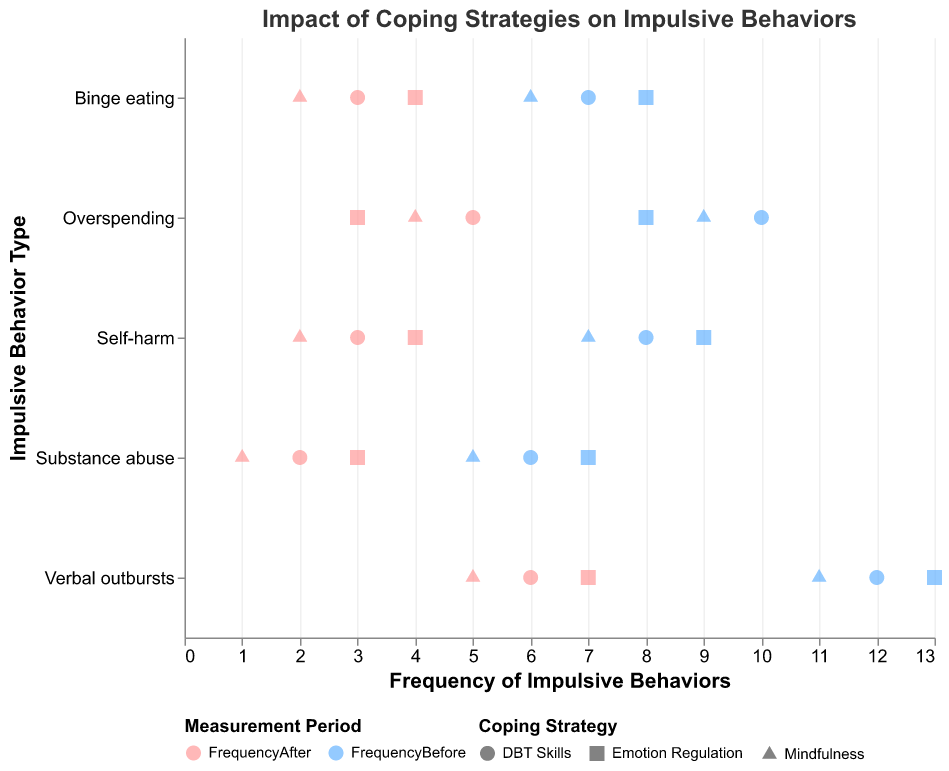What's the title of the plot? The text at the top of the plot typically represents the title, which provides a brief description of the plot's content.
Answer: Impact of Coping Strategies on Impulsive Behaviors What are the two periods represented in the plot? The legend next to the color scale provides information indicating the different periods along with their corresponding colors.
Answer: FrequencyBefore and FrequencyAfter What coping strategy is represented by the triangle shapes in the plot? The legend detailing the shape scale identifies the coping strategies along with their corresponding shapes.
Answer: Emotion Regulation Which impulsive behavior had the highest frequency before implementing coping strategies? By examining the x-values under "Frequency Before" for each behavior category on the y-axis, it's clear that "Verbal outbursts" has the highest frequency value at 13.
Answer: Verbal outbursts Which strategy seems to be most effective in reducing frequency for "substance abuse"? Compare the "FrequencyBefore" and "FrequencyAfter" values for each coping strategy applied to "substance abuse." "Mindfulness" reduces the frequency from 5 to 1, showing the largest reduction.
Answer: Mindfulness What's the average reduction in frequency for "overspending" across all coping strategies? Calculate the reductions (10-5, 9-4, and 8-3) and then average those values: ((10-5)+(9-4)+(8-3))/3 = (5+5+5)/3 = 15/3 = 5.
Answer: 5 Which behavior shows the smallest change in frequency with DBT Skills? Review the difference between "FrequencyBefore" and "FrequencyAfter" values for each behavior with DBT Skills. The smallest difference is for "substance abuse" with a reduction from 6 to 2, the smallest overall change of 4 is incorrect, it should be 6 (DBT Skills for Self-harm: 8-3=5; DBT Skills for Substance abuse: 6-2=4; DBT Skills for Overspending: 10-5=5; DBT Skills for Verbal outbursts: 12-6=6; DBT Skills for Binge eating: 7-3=4).
Answer: Substance abuse Examining "Binge eating," which coping strategy showed the least reduction in frequency? Compare the reduction amounts from each strategy for "Binge eating" ("DBT Skills" from 7 to 3, "Mindfulness" from 6 to 2, "Emotion Regulation" from 8 to 4). The least reduction is with "Emotion Regulation".
Answer: Emotion Regulation 